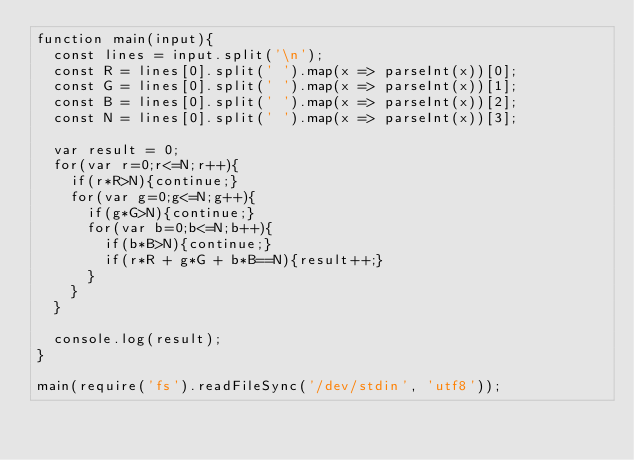Convert code to text. <code><loc_0><loc_0><loc_500><loc_500><_JavaScript_>function main(input){
  const lines = input.split('\n');
  const R = lines[0].split(' ').map(x => parseInt(x))[0];
  const G = lines[0].split(' ').map(x => parseInt(x))[1];
  const B = lines[0].split(' ').map(x => parseInt(x))[2];
  const N = lines[0].split(' ').map(x => parseInt(x))[3];

  var result = 0;
  for(var r=0;r<=N;r++){
    if(r*R>N){continue;}
    for(var g=0;g<=N;g++){
      if(g*G>N){continue;}
      for(var b=0;b<=N;b++){
        if(b*B>N){continue;}
        if(r*R + g*G + b*B==N){result++;}
      }
    }
  }

  console.log(result);
}

main(require('fs').readFileSync('/dev/stdin', 'utf8'));</code> 